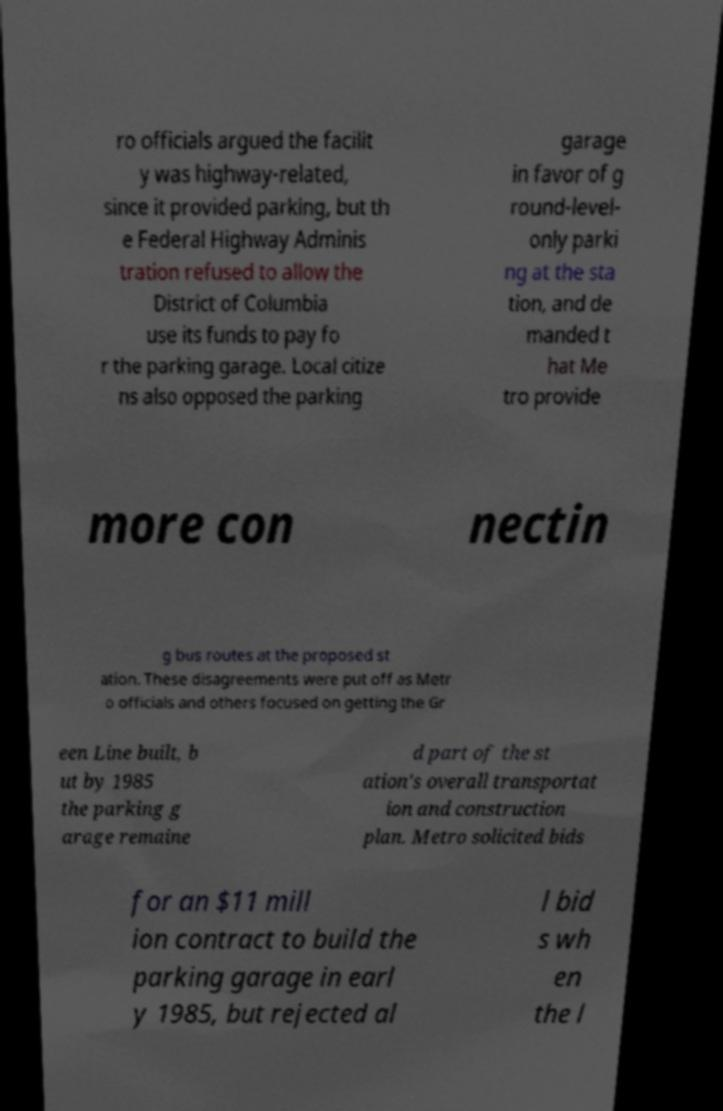Can you accurately transcribe the text from the provided image for me? ro officials argued the facilit y was highway-related, since it provided parking, but th e Federal Highway Adminis tration refused to allow the District of Columbia use its funds to pay fo r the parking garage. Local citize ns also opposed the parking garage in favor of g round-level- only parki ng at the sta tion, and de manded t hat Me tro provide more con nectin g bus routes at the proposed st ation. These disagreements were put off as Metr o officials and others focused on getting the Gr een Line built, b ut by 1985 the parking g arage remaine d part of the st ation's overall transportat ion and construction plan. Metro solicited bids for an $11 mill ion contract to build the parking garage in earl y 1985, but rejected al l bid s wh en the l 